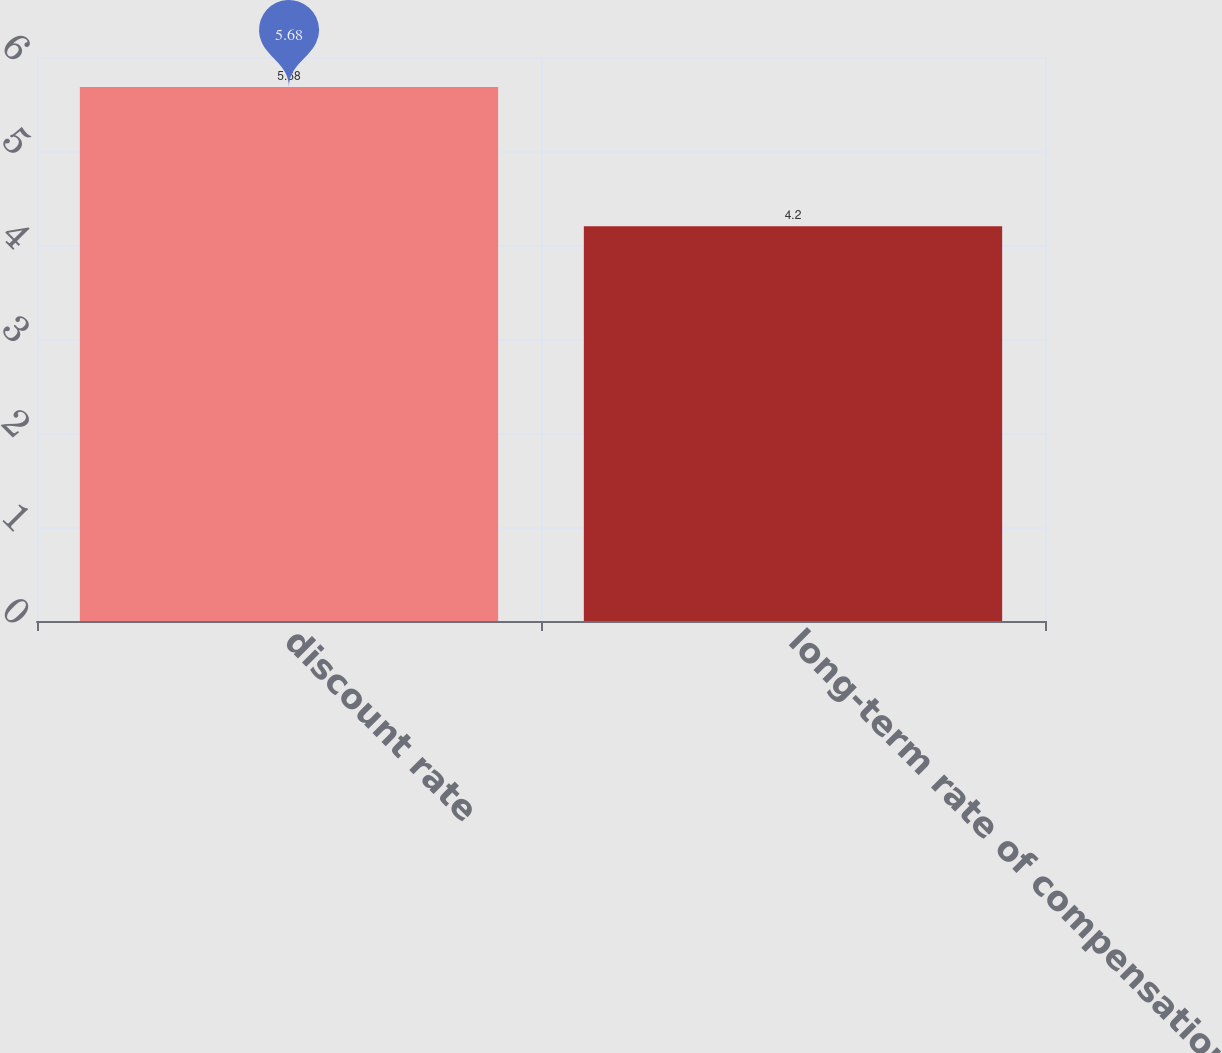Convert chart. <chart><loc_0><loc_0><loc_500><loc_500><bar_chart><fcel>discount rate<fcel>long-term rate of compensation<nl><fcel>5.68<fcel>4.2<nl></chart> 